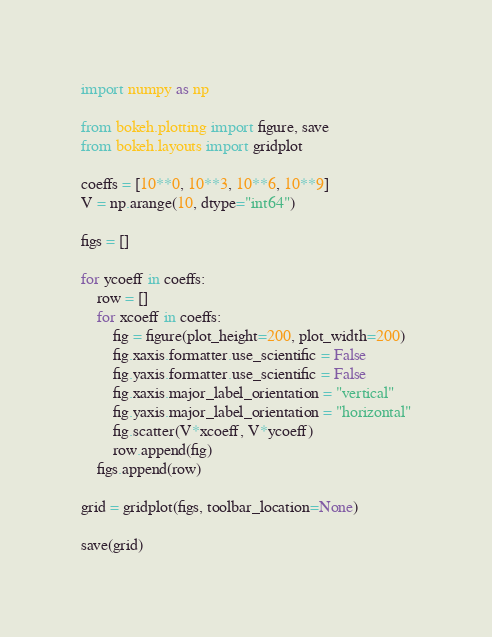<code> <loc_0><loc_0><loc_500><loc_500><_Python_>import numpy as np

from bokeh.plotting import figure, save
from bokeh.layouts import gridplot

coeffs = [10**0, 10**3, 10**6, 10**9]
V = np.arange(10, dtype="int64")

figs = []

for ycoeff in coeffs:
    row = []
    for xcoeff in coeffs:
        fig = figure(plot_height=200, plot_width=200)
        fig.xaxis.formatter.use_scientific = False
        fig.yaxis.formatter.use_scientific = False
        fig.xaxis.major_label_orientation = "vertical"
        fig.yaxis.major_label_orientation = "horizontal"
        fig.scatter(V*xcoeff, V*ycoeff)
        row.append(fig)
    figs.append(row)

grid = gridplot(figs, toolbar_location=None)

save(grid)
</code> 